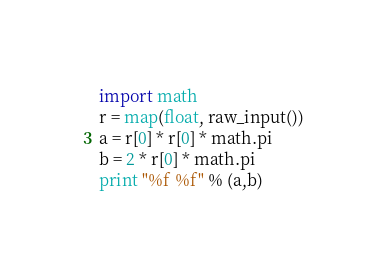<code> <loc_0><loc_0><loc_500><loc_500><_Python_>import math
r = map(float, raw_input())
a = r[0] * r[0] * math.pi
b = 2 * r[0] * math.pi
print "%f %f" % (a,b)</code> 